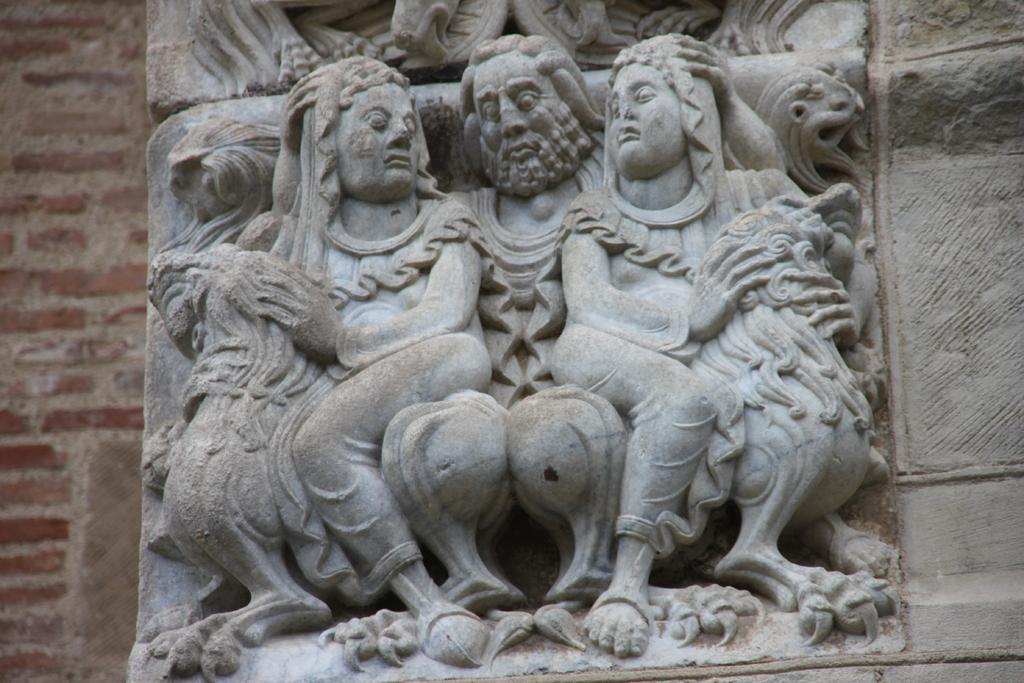What is featured on the stone in the image? There are carvings on a stone in the image. What is the color of the stone? The stone is grey in color. What do the carvings depict? The carvings depict humans. What can be seen in the background of the image? There is a wall in the background of the image. How many units of notebooks are stacked on the stone in the image? There are no notebooks present in the image; it features a stone with carvings and a wall in the background. 